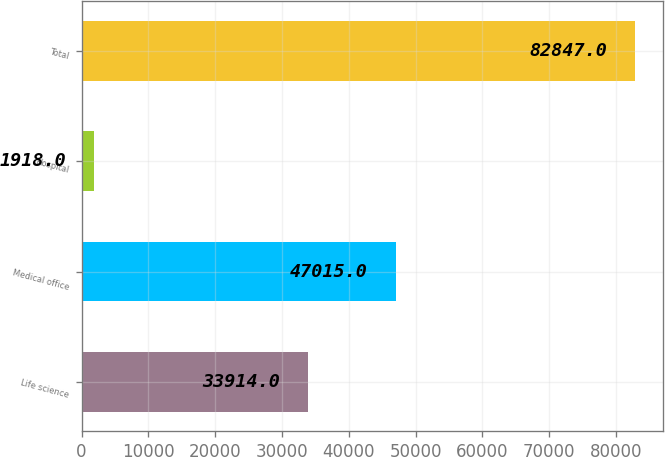<chart> <loc_0><loc_0><loc_500><loc_500><bar_chart><fcel>Life science<fcel>Medical office<fcel>Hospital<fcel>Total<nl><fcel>33914<fcel>47015<fcel>1918<fcel>82847<nl></chart> 